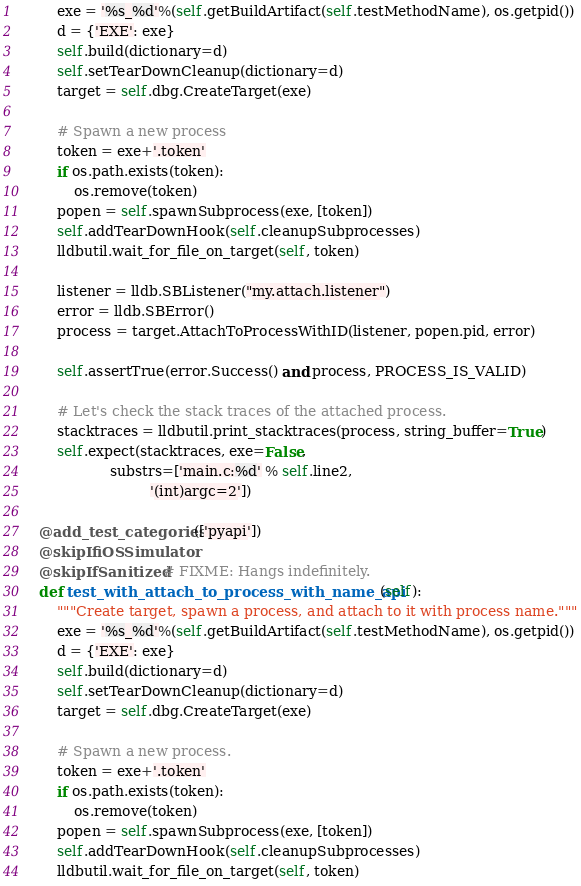<code> <loc_0><loc_0><loc_500><loc_500><_Python_>        exe = '%s_%d'%(self.getBuildArtifact(self.testMethodName), os.getpid())
        d = {'EXE': exe}
        self.build(dictionary=d)
        self.setTearDownCleanup(dictionary=d)
        target = self.dbg.CreateTarget(exe)

        # Spawn a new process
        token = exe+'.token'
        if os.path.exists(token):
            os.remove(token)
        popen = self.spawnSubprocess(exe, [token])
        self.addTearDownHook(self.cleanupSubprocesses)
        lldbutil.wait_for_file_on_target(self, token)

        listener = lldb.SBListener("my.attach.listener")
        error = lldb.SBError()
        process = target.AttachToProcessWithID(listener, popen.pid, error)

        self.assertTrue(error.Success() and process, PROCESS_IS_VALID)

        # Let's check the stack traces of the attached process.
        stacktraces = lldbutil.print_stacktraces(process, string_buffer=True)
        self.expect(stacktraces, exe=False,
                    substrs=['main.c:%d' % self.line2,
                             '(int)argc=2'])

    @add_test_categories(['pyapi'])
    @skipIfiOSSimulator
    @skipIfSanitized # FIXME: Hangs indefinitely.
    def test_with_attach_to_process_with_name_api(self):
        """Create target, spawn a process, and attach to it with process name."""
        exe = '%s_%d'%(self.getBuildArtifact(self.testMethodName), os.getpid())
        d = {'EXE': exe}
        self.build(dictionary=d)
        self.setTearDownCleanup(dictionary=d)
        target = self.dbg.CreateTarget(exe)

        # Spawn a new process.
        token = exe+'.token'
        if os.path.exists(token):
            os.remove(token)
        popen = self.spawnSubprocess(exe, [token])
        self.addTearDownHook(self.cleanupSubprocesses)
        lldbutil.wait_for_file_on_target(self, token)
</code> 